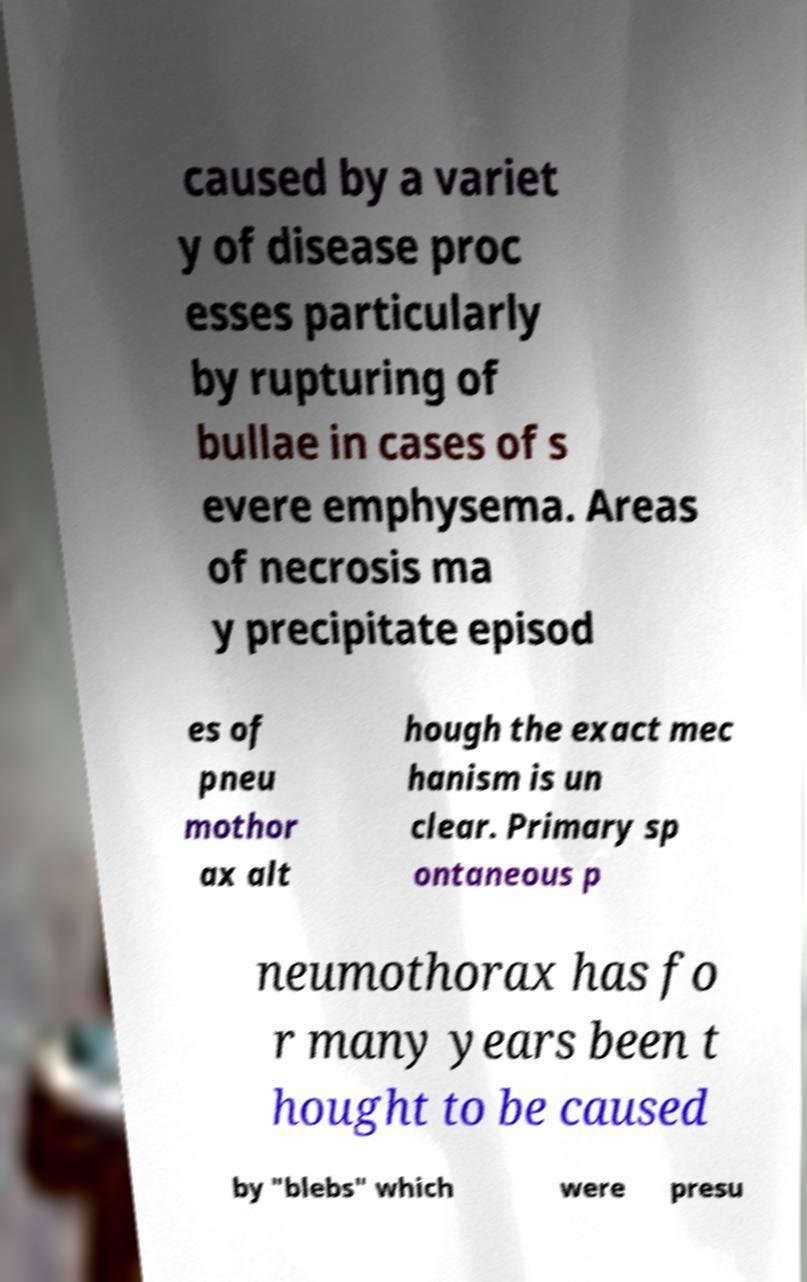Please identify and transcribe the text found in this image. caused by a variet y of disease proc esses particularly by rupturing of bullae in cases of s evere emphysema. Areas of necrosis ma y precipitate episod es of pneu mothor ax alt hough the exact mec hanism is un clear. Primary sp ontaneous p neumothorax has fo r many years been t hought to be caused by "blebs" which were presu 